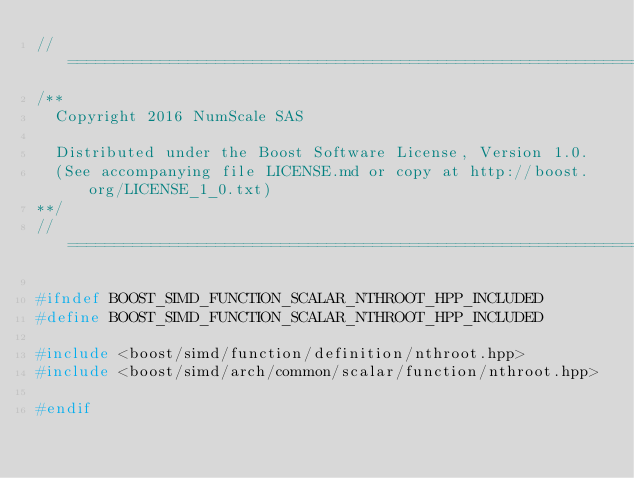Convert code to text. <code><loc_0><loc_0><loc_500><loc_500><_C++_>//==================================================================================================
/**
  Copyright 2016 NumScale SAS

  Distributed under the Boost Software License, Version 1.0.
  (See accompanying file LICENSE.md or copy at http://boost.org/LICENSE_1_0.txt)
**/
//==================================================================================================

#ifndef BOOST_SIMD_FUNCTION_SCALAR_NTHROOT_HPP_INCLUDED
#define BOOST_SIMD_FUNCTION_SCALAR_NTHROOT_HPP_INCLUDED

#include <boost/simd/function/definition/nthroot.hpp>
#include <boost/simd/arch/common/scalar/function/nthroot.hpp>

#endif
</code> 